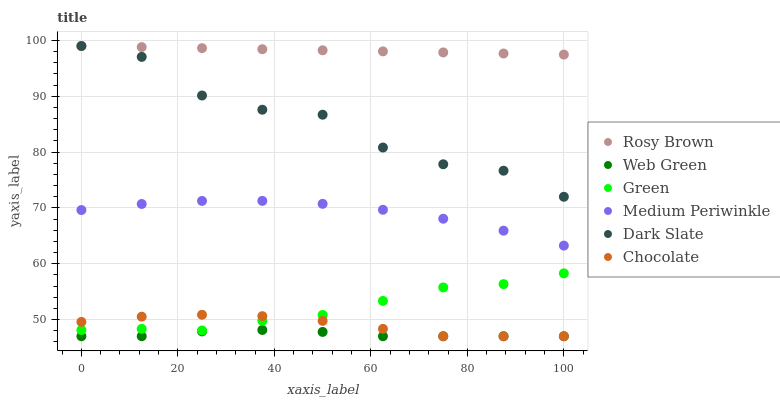Does Web Green have the minimum area under the curve?
Answer yes or no. Yes. Does Rosy Brown have the maximum area under the curve?
Answer yes or no. Yes. Does Medium Periwinkle have the minimum area under the curve?
Answer yes or no. No. Does Medium Periwinkle have the maximum area under the curve?
Answer yes or no. No. Is Rosy Brown the smoothest?
Answer yes or no. Yes. Is Dark Slate the roughest?
Answer yes or no. Yes. Is Medium Periwinkle the smoothest?
Answer yes or no. No. Is Medium Periwinkle the roughest?
Answer yes or no. No. Does Web Green have the lowest value?
Answer yes or no. Yes. Does Medium Periwinkle have the lowest value?
Answer yes or no. No. Does Dark Slate have the highest value?
Answer yes or no. Yes. Does Medium Periwinkle have the highest value?
Answer yes or no. No. Is Web Green less than Green?
Answer yes or no. Yes. Is Medium Periwinkle greater than Web Green?
Answer yes or no. Yes. Does Rosy Brown intersect Dark Slate?
Answer yes or no. Yes. Is Rosy Brown less than Dark Slate?
Answer yes or no. No. Is Rosy Brown greater than Dark Slate?
Answer yes or no. No. Does Web Green intersect Green?
Answer yes or no. No. 